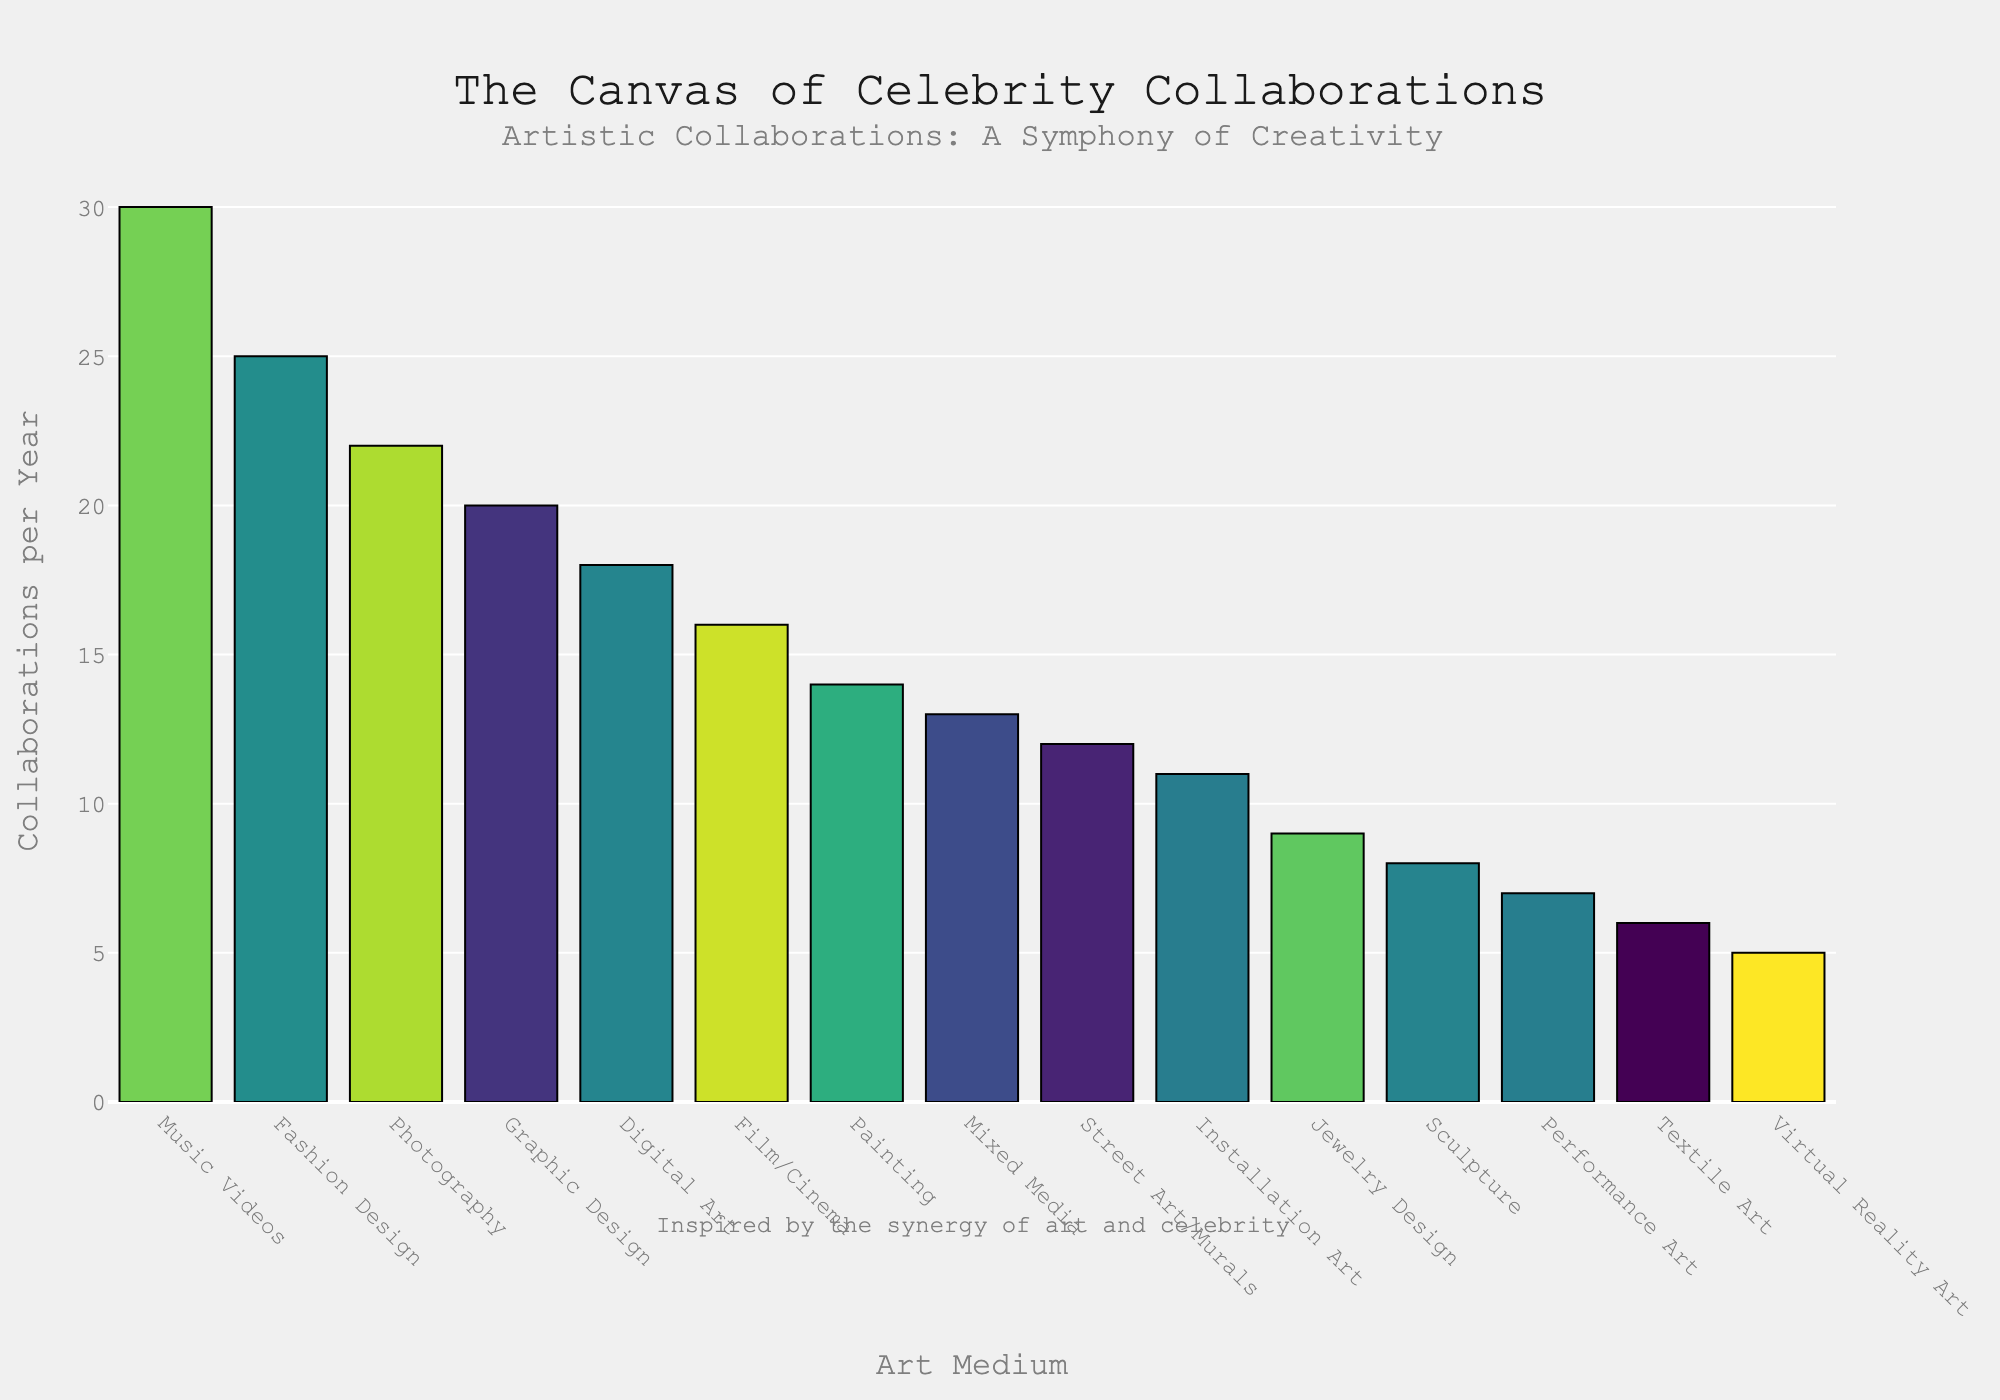Which art medium has the highest number of collaborations per year? To find this, look for the tallest bar in the figure. The bar representing Music Videos is the tallest, indicating it has the highest number of collaborations per year, which is 30.
Answer: Music Videos Which art medium has the fewest collaborations per year? For the fewest, look for the shortest bar in the chart. The Virtual Reality Art bar is the shortest, indicating it has the least number of collaborations per year, which is 5.
Answer: Virtual Reality Art What is the total number of collaborations per year for Painting, Sculpture, and Street Art/Murals combined? Add the numbers for these mediums: Painting (14) + Sculpture (8) + Street Art/Murals (12). Thus, 14 + 8 + 12 = 34.
Answer: 34 How many more collaborations per year does Fashion Design have compared to Digital Art? Check the heights of the Fashion Design and Digital Art bars, then subtract Digital Art's value from Fashion Design's. Fashion Design has 25, and Digital Art has 18, so 25 - 18 = 7.
Answer: 7 Is the number of collaborations in Film/Cinema greater than that in Installation Art? Compare the heights of the bars for Film/Cinema (16) and Installation Art (11). Since 16 is greater than 11, the answer is yes.
Answer: Yes What is the sum of collaborations per year for the top three art mediums? Identify the top three: Music Videos (30), Fashion Design (25), and Photography (22). Add these values together: 30 + 25 + 22 = 77.
Answer: 77 Which art medium lies in the middle when sorted by collaborations per year? When the data is sorted, the middle value (8th out of 15) represents the median. In the sorted data, this is Installation Art, which has 11 collaborations per year.
Answer: Installation Art How many art mediums have collaborations per year greater than 15? Count the bars with values greater than 15. These are Photography (22), Digital Art (18), Fashion Design (25), Music Videos (30), Graphic Design (20), and Film/Cinema (16), making a total of 6 mediums.
Answer: 6 By how much do collaborations in Painting fall short of those in Graphic Design? Subtract the number of collaborations in Painting (14) from those in Graphic Design (20). So, 20 - 14 = 6.
Answer: 6 What is the average number of collaborations per year for Digital Art, Performance Art, and Mixed Media? Add their values and then divide by the number of mediums: (Digital Art 18 + Performance Art 7 + Mixed Media 13) ÷ 3 = 38 ÷ 3 ≈ 12.67.
Answer: 12.67 